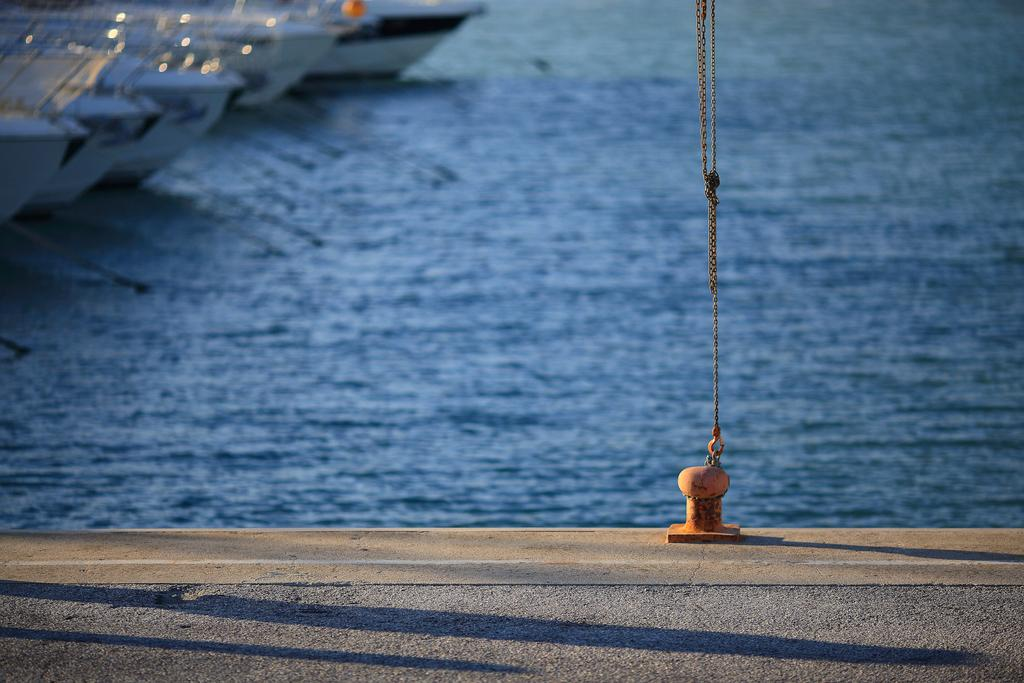What type of body of water is present in the image? There is a lake in the picture. What can be seen in the top left corner of the image? There are boats visible in the top left corner of the image. What is located at the bottom of the image? There is a road at the bottom of the image. What is the chain attached to on the right side of the image? There is a chain attached to a rod on the right side of the image. What type of feather can be seen floating on the lake in the image? There is no feather visible in the image; it only shows a lake, boats, a road, and a chain attached to a rod. 